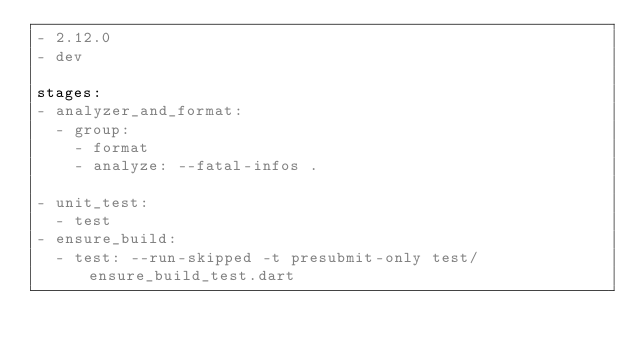Convert code to text. <code><loc_0><loc_0><loc_500><loc_500><_YAML_>- 2.12.0
- dev

stages:
- analyzer_and_format:
  - group:
    - format
    - analyze: --fatal-infos .

- unit_test:
  - test
- ensure_build:
  - test: --run-skipped -t presubmit-only test/ensure_build_test.dart
</code> 